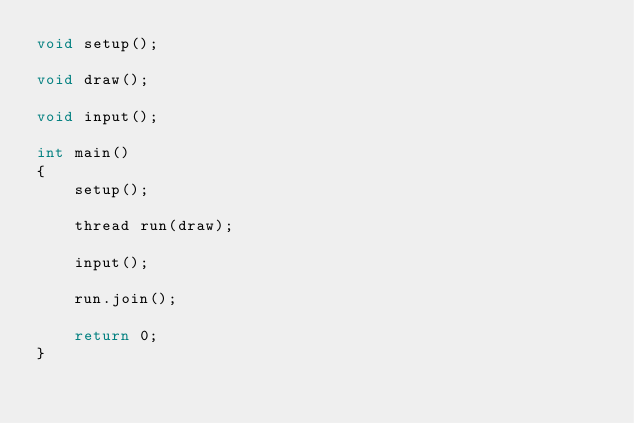<code> <loc_0><loc_0><loc_500><loc_500><_C++_>void setup();

void draw();

void input();

int main()
{
	setup();

	thread run(draw);

	input();

	run.join();

	return 0;
}


</code> 